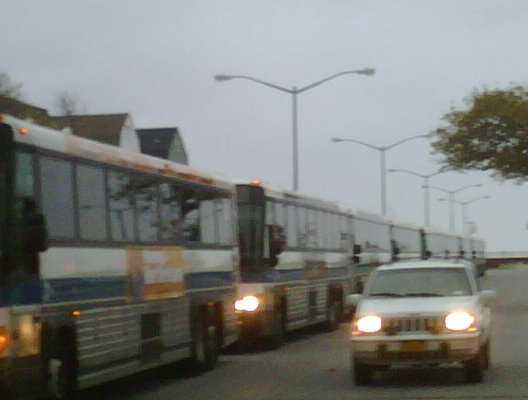Describe the objects in this image and their specific colors. I can see bus in darkgray, black, and gray tones, bus in darkgray, gray, and black tones, truck in darkgray, gray, and black tones, car in darkgray, gray, and black tones, and bus in darkgray, gray, and black tones in this image. 